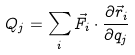<formula> <loc_0><loc_0><loc_500><loc_500>Q _ { j } = \sum _ { i } \vec { F } _ { i } \cdot \frac { \partial \vec { r } _ { i } } { \partial q _ { j } }</formula> 